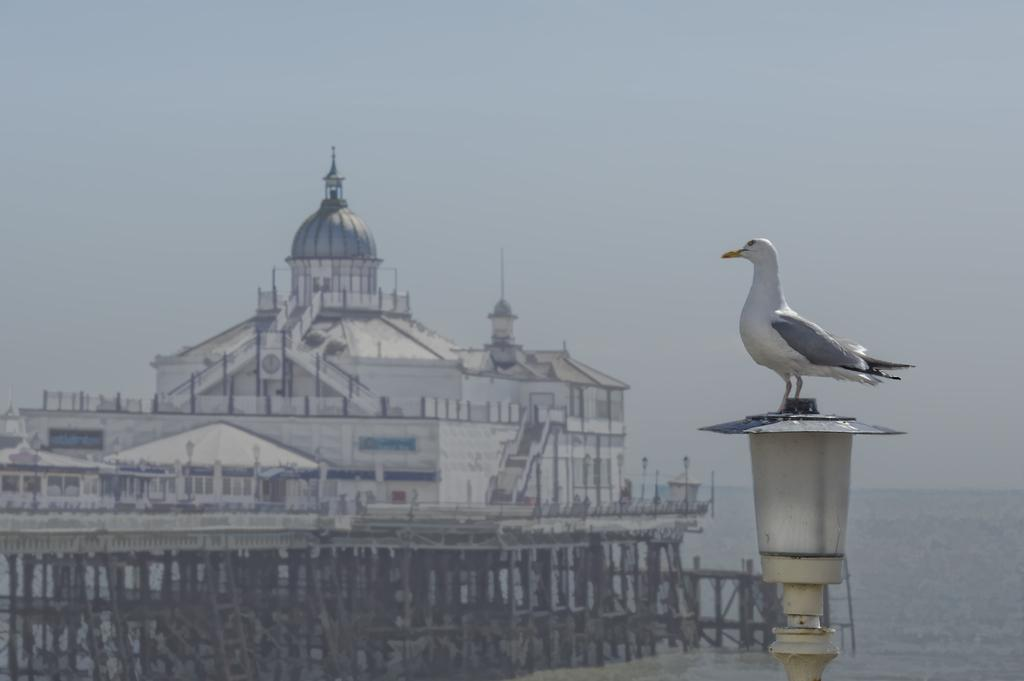What is the bird perched on in the image? There is a bird on a lamp in the image. What can be seen on the left side of the image? There is a building on the left side of the image. What objects are present in the image that might be used for climbing or reaching higher places? There are ladders in the image. What natural element is visible in the image? There is water visible in the image. What type of religious symbol can be seen on the bird in the image? There is no religious symbol present on the bird in the image. Is there a basketball court visible in the image? There is no basketball court present in the image. 